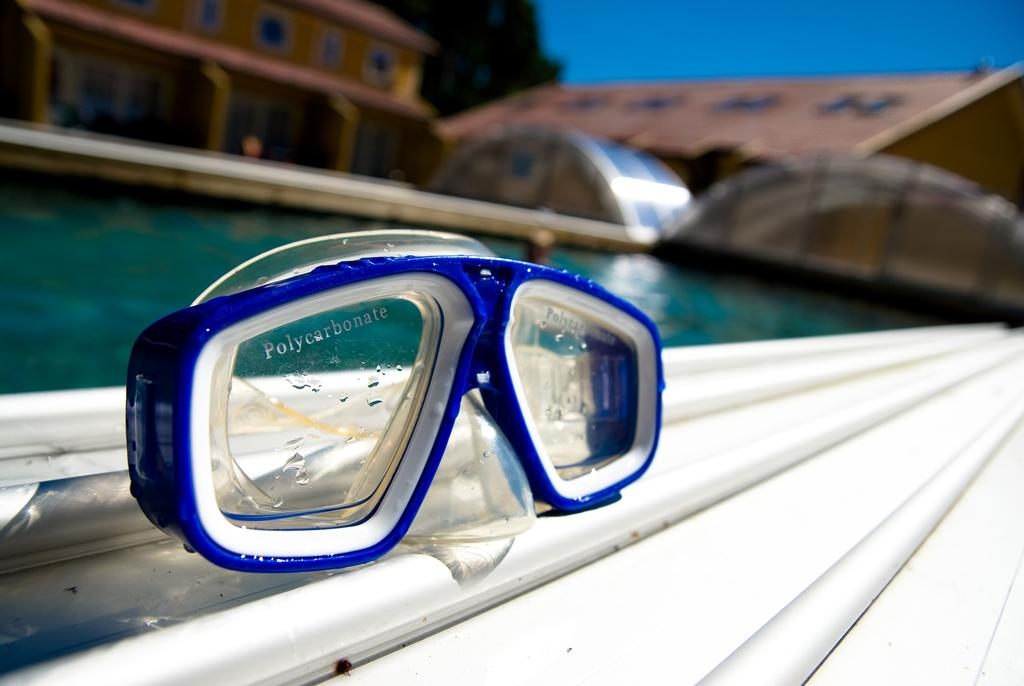What type of equipment is visible in the image? There are swimming goggles in the image. How are the swimming goggles positioned in the image? The swimming goggles are placed over a surface. What can be seen in the background of the image? There is a pool filled with water in the image. Can you describe the quality of the image? The image is blurry. What does the caption on the swimming goggles say in the image? There is no caption visible on the swimming goggles in the image. Can you tell me the doctor's name who is wearing the swimming goggles in the image? There is no doctor present in the image, only swimming goggles. 